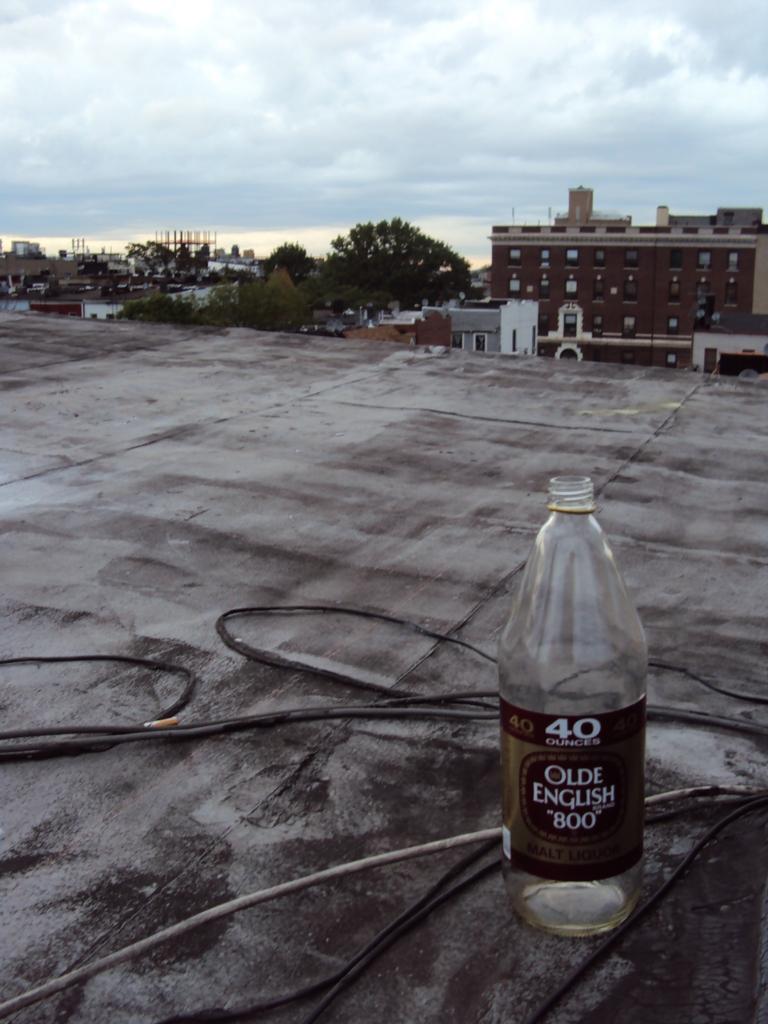What brand of bottle?
Your answer should be compact. Olde english 800. 